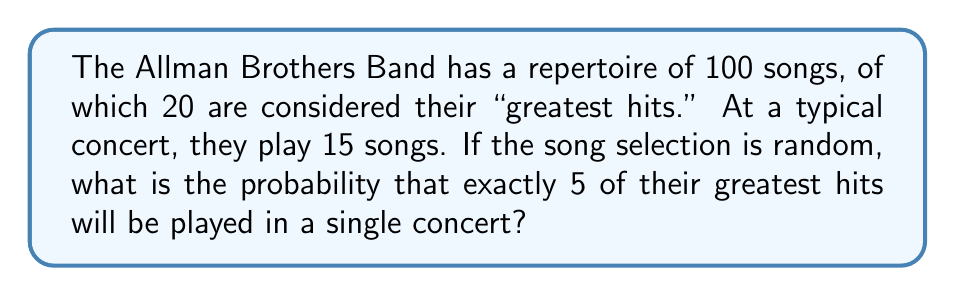Provide a solution to this math problem. To solve this problem, we'll use the hypergeometric distribution, which is appropriate for sampling without replacement.

Let's define our variables:
- N = 100 (total number of songs in repertoire)
- K = 20 (number of greatest hits)
- n = 15 (number of songs played in a concert)
- k = 5 (number of greatest hits we want to be played)

The probability mass function for the hypergeometric distribution is:

$$ P(X = k) = \frac{\binom{K}{k} \binom{N-K}{n-k}}{\binom{N}{n}} $$

where $\binom{a}{b}$ represents the binomial coefficient.

Let's calculate each part:

1) $\binom{K}{k} = \binom{20}{5} = 15,504$

2) $\binom{N-K}{n-k} = \binom{80}{10} = 3,129,170,672$

3) $\binom{N}{n} = \binom{100}{15} = 253,338,471,349,988$

Now, let's substitute these values into our probability mass function:

$$ P(X = 5) = \frac{15,504 \times 3,129,170,672}{253,338,471,349,988} $$

$$ P(X = 5) = \frac{48,516,901,699,328}{253,338,471,349,988} $$

$$ P(X = 5) \approx 0.1915 $$
Answer: The probability of exactly 5 greatest hits being played in a single concert is approximately 0.1915 or 19.15%. 